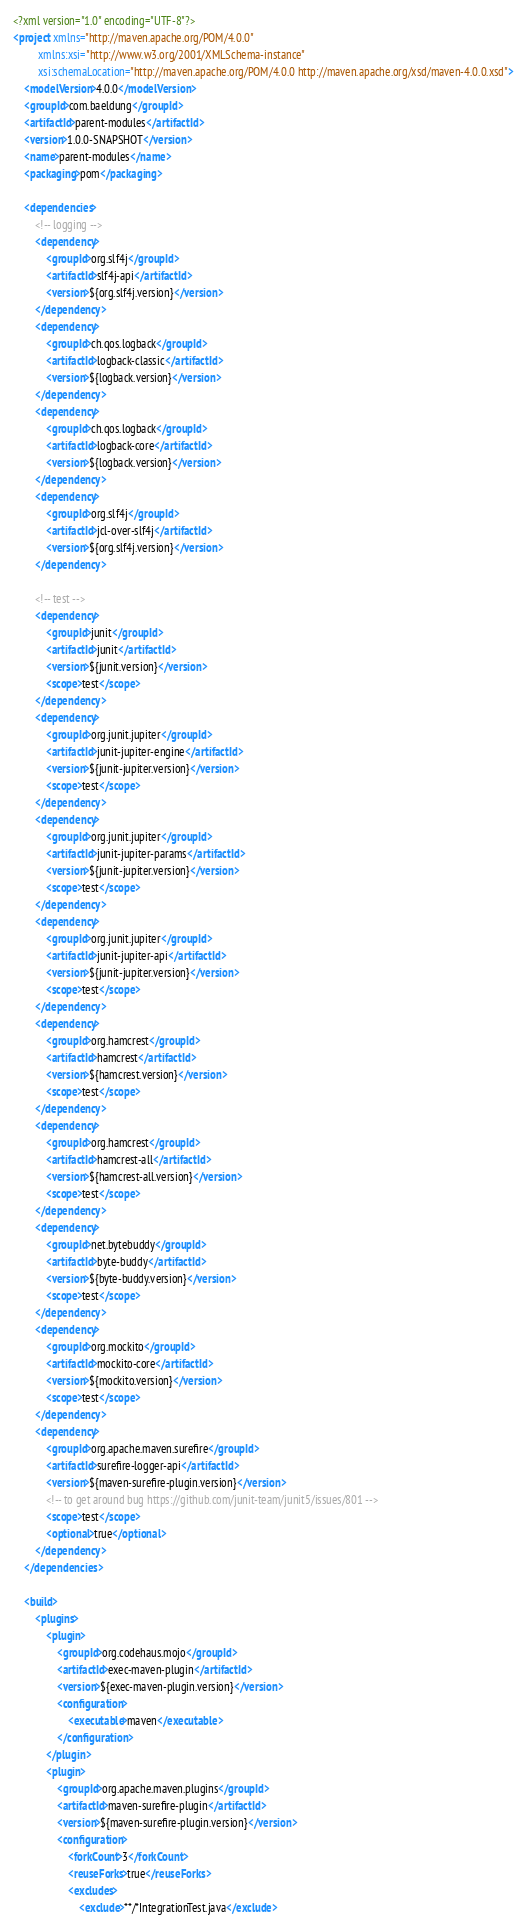Convert code to text. <code><loc_0><loc_0><loc_500><loc_500><_XML_><?xml version="1.0" encoding="UTF-8"?>
<project xmlns="http://maven.apache.org/POM/4.0.0"
         xmlns:xsi="http://www.w3.org/2001/XMLSchema-instance"
         xsi:schemaLocation="http://maven.apache.org/POM/4.0.0 http://maven.apache.org/xsd/maven-4.0.0.xsd">
    <modelVersion>4.0.0</modelVersion>
    <groupId>com.baeldung</groupId>
    <artifactId>parent-modules</artifactId>
    <version>1.0.0-SNAPSHOT</version>
    <name>parent-modules</name>
    <packaging>pom</packaging>

    <dependencies>
        <!-- logging -->
        <dependency>
            <groupId>org.slf4j</groupId>
            <artifactId>slf4j-api</artifactId>
            <version>${org.slf4j.version}</version>
        </dependency>
        <dependency>
            <groupId>ch.qos.logback</groupId>
            <artifactId>logback-classic</artifactId>
            <version>${logback.version}</version>
        </dependency>
        <dependency>
            <groupId>ch.qos.logback</groupId>
            <artifactId>logback-core</artifactId>
            <version>${logback.version}</version>
        </dependency>
        <dependency>
            <groupId>org.slf4j</groupId>
            <artifactId>jcl-over-slf4j</artifactId>
            <version>${org.slf4j.version}</version>
        </dependency>

        <!-- test -->
        <dependency>
            <groupId>junit</groupId>
            <artifactId>junit</artifactId>
            <version>${junit.version}</version>
            <scope>test</scope>
        </dependency>
        <dependency>
            <groupId>org.junit.jupiter</groupId>
            <artifactId>junit-jupiter-engine</artifactId>
            <version>${junit-jupiter.version}</version>
            <scope>test</scope>
        </dependency>
        <dependency>
            <groupId>org.junit.jupiter</groupId>
            <artifactId>junit-jupiter-params</artifactId>
            <version>${junit-jupiter.version}</version>
            <scope>test</scope>
        </dependency>
        <dependency>
            <groupId>org.junit.jupiter</groupId>
            <artifactId>junit-jupiter-api</artifactId>
            <version>${junit-jupiter.version}</version>
            <scope>test</scope>
        </dependency>
        <dependency>
            <groupId>org.hamcrest</groupId>
            <artifactId>hamcrest</artifactId>
            <version>${hamcrest.version}</version>
            <scope>test</scope>
        </dependency>
        <dependency>
            <groupId>org.hamcrest</groupId>
            <artifactId>hamcrest-all</artifactId>
            <version>${hamcrest-all.version}</version>
            <scope>test</scope>
        </dependency>
        <dependency>
            <groupId>net.bytebuddy</groupId>
            <artifactId>byte-buddy</artifactId>
            <version>${byte-buddy.version}</version>
            <scope>test</scope>
        </dependency>
        <dependency>
            <groupId>org.mockito</groupId>
            <artifactId>mockito-core</artifactId>
            <version>${mockito.version}</version>
            <scope>test</scope>
        </dependency>
        <dependency>
            <groupId>org.apache.maven.surefire</groupId>
            <artifactId>surefire-logger-api</artifactId>
            <version>${maven-surefire-plugin.version}</version>
            <!-- to get around bug https://github.com/junit-team/junit5/issues/801 -->
            <scope>test</scope>
            <optional>true</optional>
        </dependency>
    </dependencies>

    <build>
        <plugins>
            <plugin>
                <groupId>org.codehaus.mojo</groupId>
                <artifactId>exec-maven-plugin</artifactId>
                <version>${exec-maven-plugin.version}</version>
                <configuration>
                    <executable>maven</executable>
                </configuration>
            </plugin>
            <plugin>
                <groupId>org.apache.maven.plugins</groupId>
                <artifactId>maven-surefire-plugin</artifactId>
                <version>${maven-surefire-plugin.version}</version>
                <configuration>
                    <forkCount>3</forkCount>
                    <reuseForks>true</reuseForks>
                    <excludes>
                        <exclude>**/*IntegrationTest.java</exclude></code> 